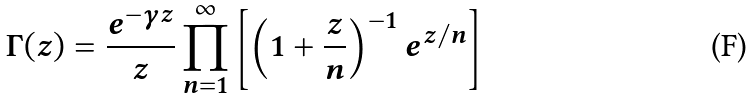Convert formula to latex. <formula><loc_0><loc_0><loc_500><loc_500>\Gamma ( z ) = { \frac { e ^ { - \gamma z } } { z } } \prod _ { n = 1 } ^ { \infty } \left [ \left ( 1 + { \frac { z } { n } } \right ) ^ { - 1 } e ^ { z / n } \right ]</formula> 